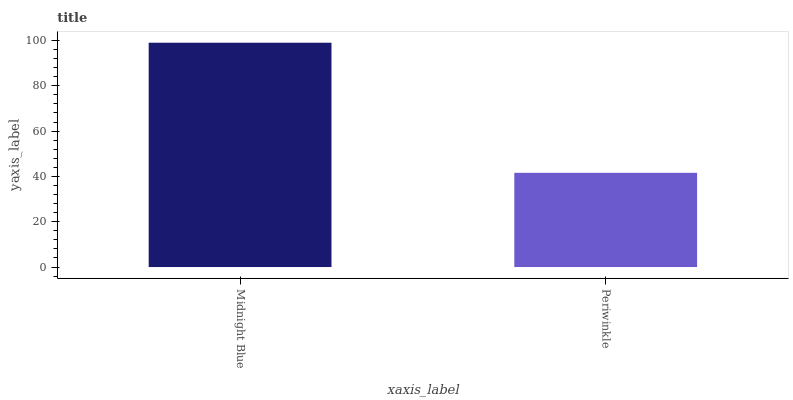Is Periwinkle the maximum?
Answer yes or no. No. Is Midnight Blue greater than Periwinkle?
Answer yes or no. Yes. Is Periwinkle less than Midnight Blue?
Answer yes or no. Yes. Is Periwinkle greater than Midnight Blue?
Answer yes or no. No. Is Midnight Blue less than Periwinkle?
Answer yes or no. No. Is Midnight Blue the high median?
Answer yes or no. Yes. Is Periwinkle the low median?
Answer yes or no. Yes. Is Periwinkle the high median?
Answer yes or no. No. Is Midnight Blue the low median?
Answer yes or no. No. 